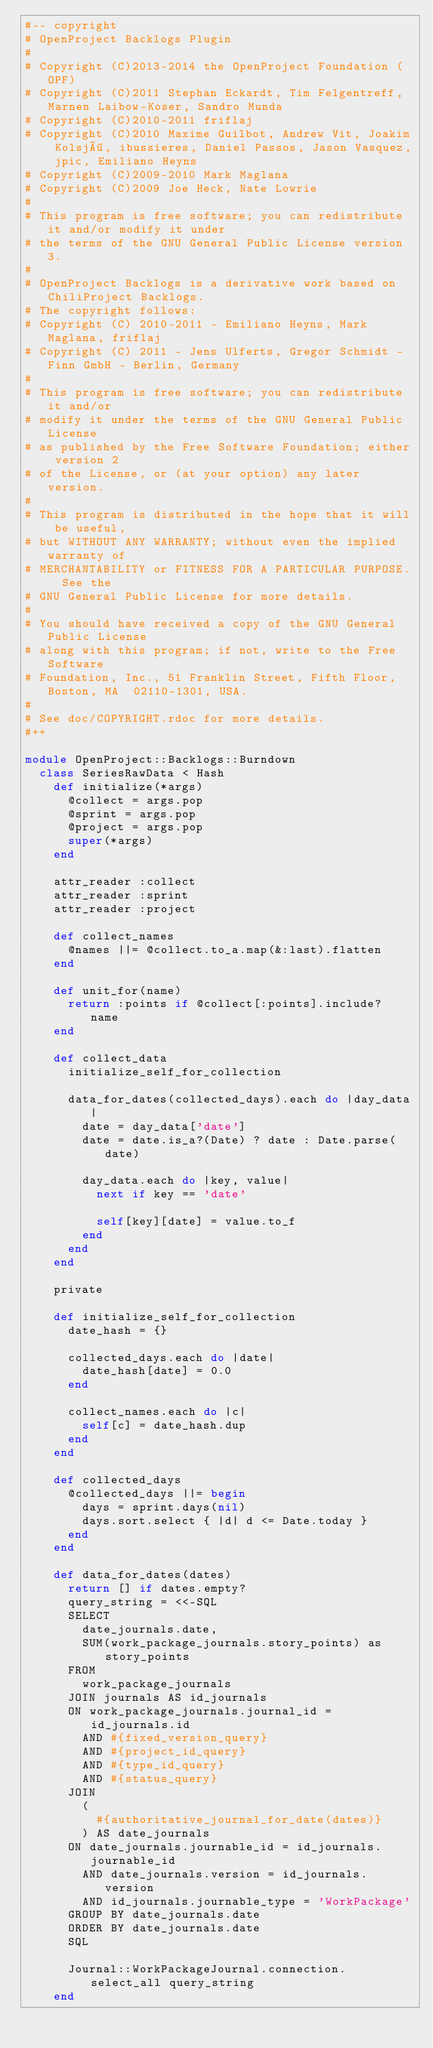Convert code to text. <code><loc_0><loc_0><loc_500><loc_500><_Ruby_>#-- copyright
# OpenProject Backlogs Plugin
#
# Copyright (C)2013-2014 the OpenProject Foundation (OPF)
# Copyright (C)2011 Stephan Eckardt, Tim Felgentreff, Marnen Laibow-Koser, Sandro Munda
# Copyright (C)2010-2011 friflaj
# Copyright (C)2010 Maxime Guilbot, Andrew Vit, Joakim Kolsjö, ibussieres, Daniel Passos, Jason Vasquez, jpic, Emiliano Heyns
# Copyright (C)2009-2010 Mark Maglana
# Copyright (C)2009 Joe Heck, Nate Lowrie
#
# This program is free software; you can redistribute it and/or modify it under
# the terms of the GNU General Public License version 3.
#
# OpenProject Backlogs is a derivative work based on ChiliProject Backlogs.
# The copyright follows:
# Copyright (C) 2010-2011 - Emiliano Heyns, Mark Maglana, friflaj
# Copyright (C) 2011 - Jens Ulferts, Gregor Schmidt - Finn GmbH - Berlin, Germany
#
# This program is free software; you can redistribute it and/or
# modify it under the terms of the GNU General Public License
# as published by the Free Software Foundation; either version 2
# of the License, or (at your option) any later version.
#
# This program is distributed in the hope that it will be useful,
# but WITHOUT ANY WARRANTY; without even the implied warranty of
# MERCHANTABILITY or FITNESS FOR A PARTICULAR PURPOSE.  See the
# GNU General Public License for more details.
#
# You should have received a copy of the GNU General Public License
# along with this program; if not, write to the Free Software
# Foundation, Inc., 51 Franklin Street, Fifth Floor, Boston, MA  02110-1301, USA.
#
# See doc/COPYRIGHT.rdoc for more details.
#++

module OpenProject::Backlogs::Burndown
  class SeriesRawData < Hash
    def initialize(*args)
      @collect = args.pop
      @sprint = args.pop
      @project = args.pop
      super(*args)
    end

    attr_reader :collect
    attr_reader :sprint
    attr_reader :project

    def collect_names
      @names ||= @collect.to_a.map(&:last).flatten
    end

    def unit_for(name)
      return :points if @collect[:points].include? name
    end

    def collect_data
      initialize_self_for_collection

      data_for_dates(collected_days).each do |day_data|
        date = day_data['date']
        date = date.is_a?(Date) ? date : Date.parse(date)

        day_data.each do |key, value|
          next if key == 'date'

          self[key][date] = value.to_f
        end
      end
    end

    private

    def initialize_self_for_collection
      date_hash = {}

      collected_days.each do |date|
        date_hash[date] = 0.0
      end

      collect_names.each do |c|
        self[c] = date_hash.dup
      end
    end

    def collected_days
      @collected_days ||= begin
        days = sprint.days(nil)
        days.sort.select { |d| d <= Date.today }
      end
    end

    def data_for_dates(dates)
      return [] if dates.empty?
      query_string = <<-SQL
      SELECT
        date_journals.date,
        SUM(work_package_journals.story_points) as story_points
      FROM
        work_package_journals
      JOIN journals AS id_journals
      ON work_package_journals.journal_id = id_journals.id
        AND #{fixed_version_query}
        AND #{project_id_query}
        AND #{type_id_query}
        AND #{status_query}
      JOIN
        (
          #{authoritative_journal_for_date(dates)}
        ) AS date_journals
      ON date_journals.journable_id = id_journals.journable_id
        AND date_journals.version = id_journals.version
        AND id_journals.journable_type = 'WorkPackage'
      GROUP BY date_journals.date
      ORDER BY date_journals.date
      SQL

      Journal::WorkPackageJournal.connection.select_all query_string
    end
</code> 